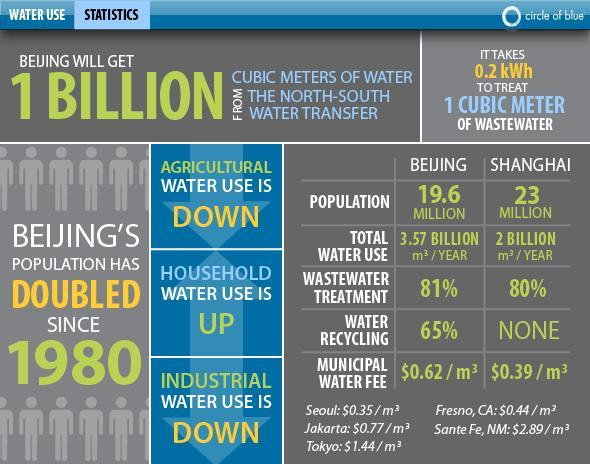What is the percentage of water recycling in  Beijing and Shanghai, taken together?
Answer the question with a short phrase. 65% What is the percentage of wastewater treatment in  Beijing and Shanghai, taken together? 161% 